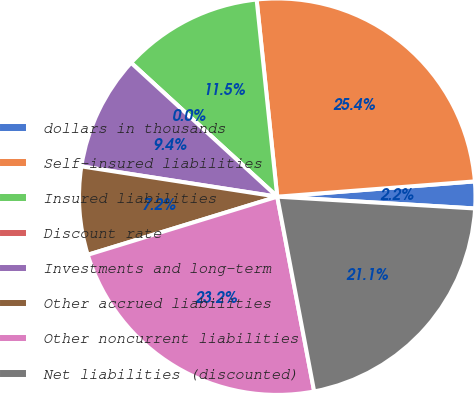Convert chart to OTSL. <chart><loc_0><loc_0><loc_500><loc_500><pie_chart><fcel>dollars in thousands<fcel>Self-insured liabilities<fcel>Insured liabilities<fcel>Discount rate<fcel>Investments and long-term<fcel>Other accrued liabilities<fcel>Other noncurrent liabilities<fcel>Net liabilities (discounted)<nl><fcel>2.18%<fcel>25.43%<fcel>11.54%<fcel>0.0%<fcel>9.36%<fcel>7.18%<fcel>23.25%<fcel>21.07%<nl></chart> 